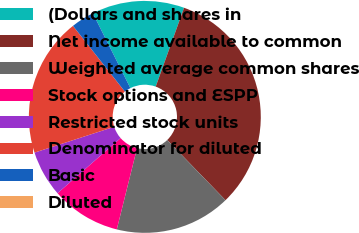Convert chart. <chart><loc_0><loc_0><loc_500><loc_500><pie_chart><fcel>(Dollars and shares in<fcel>Net income available to common<fcel>Weighted average common shares<fcel>Stock options and ESPP<fcel>Restricted stock units<fcel>Denominator for diluted<fcel>Basic<fcel>Diluted<nl><fcel>12.9%<fcel>32.26%<fcel>16.13%<fcel>9.68%<fcel>6.45%<fcel>19.35%<fcel>3.23%<fcel>0.0%<nl></chart> 